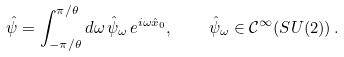Convert formula to latex. <formula><loc_0><loc_0><loc_500><loc_500>\hat { \psi } = \int _ { - \pi / \theta } ^ { \pi / \theta } d \omega \, \hat { \psi } _ { \omega } \, e ^ { i \omega \hat { x } _ { 0 } } , \quad \hat { \psi } _ { \omega } \in \mathcal { C } ^ { \infty } ( S U ( 2 ) ) \, .</formula> 